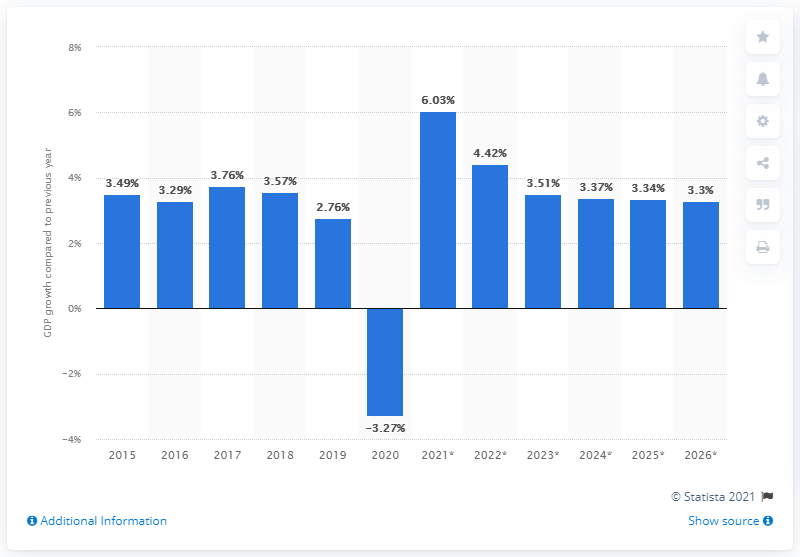Specify some key components in this picture. The global economy fell by 3.3% in 2020 compared to the previous year. 